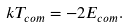Convert formula to latex. <formula><loc_0><loc_0><loc_500><loc_500>k T _ { c o m } = - 2 E _ { c o m } .</formula> 